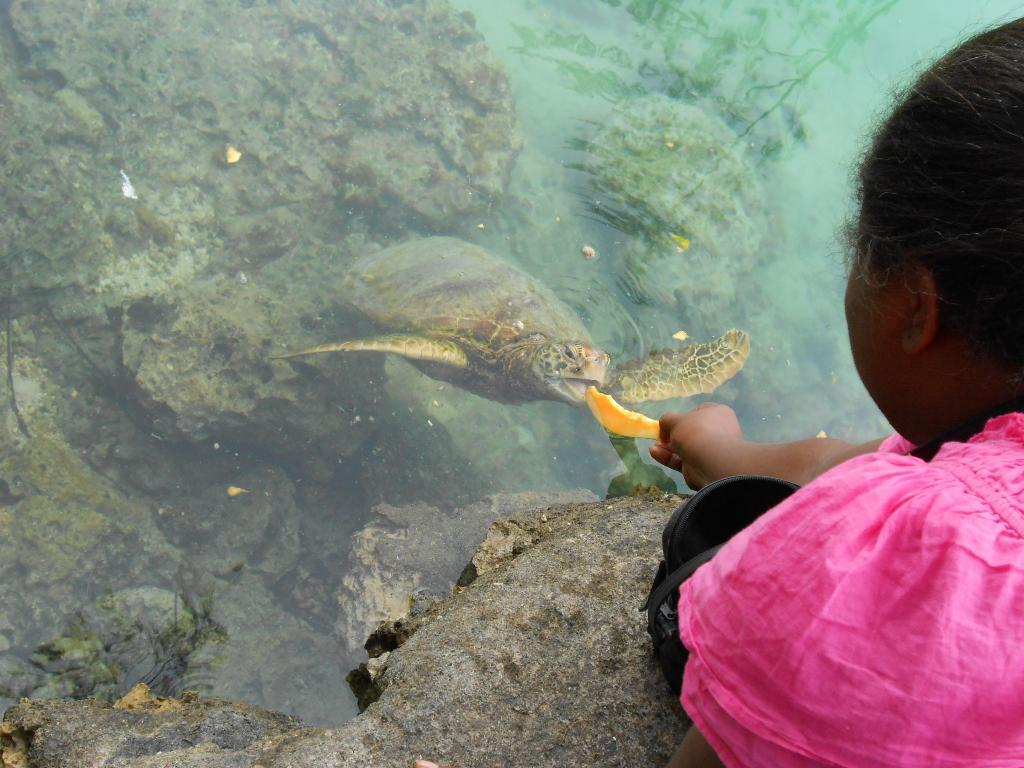What animal is in the water in the image? There is a turtle in the water in the image. What else can be seen in the image besides the turtle? There are rocks visible in the image. What is the person holding in the image? The person is holding a piece of fruit. What is the person doing with the fruit? The person is feeding the turtle. Where is the seat located in the image? There is no seat present in the image. What type of advertisement can be seen on the turtle's shell in the image? There is no advertisement on the turtle's shell in the image; it is a natural scene with a person feeding a turtle. 